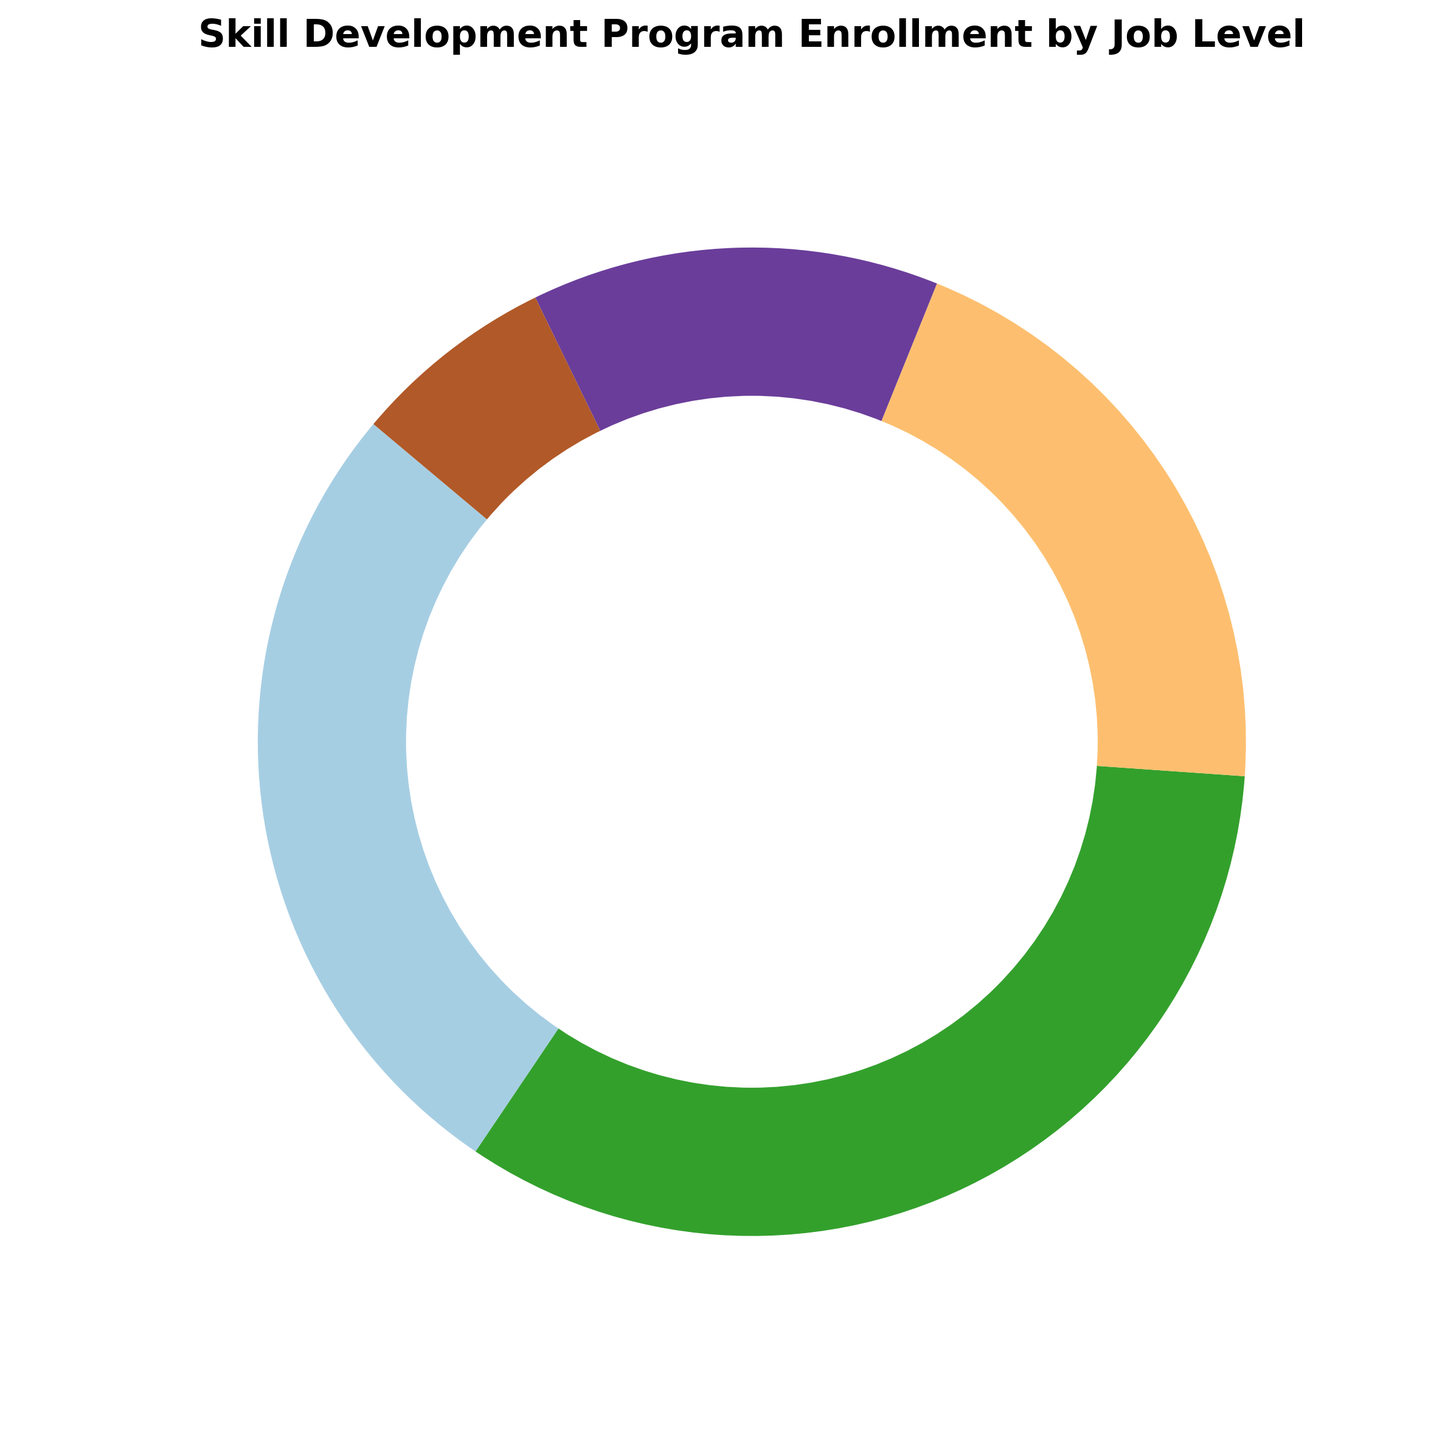What percentage of enrollment is contributed by entry-level employees? The entry-level segment on the pie chart is labeled with its enrollment percentage, showing 120 out of the total 450 enrollments. The label displays 26.7%, calculated as (120/450)*100.
Answer: 26.7% Which job level has the least enrollment in the skill development program? Observing the pie chart, the smallest slice corresponds to the Executive level, with the label showing the enrollment count of 30.
Answer: Executive How does the enrollment for mid-level employees compare to that of managerial employees? The pie chart shows that mid-level employees account for 150 enrollments while managerial employees have 60 enrollments. Thus, mid-level enrollment is 2.5 times higher than managerial enrollment.
Answer: Mid-Level has more What is the total enrollment for senior-level and executive-level employees? Adding the counts for senior-level (90) and executive-level (30) from the pie chart, the combined total is 120.
Answer: 120 Is the enrollment for senior-level employees more than 1/5 of the total enrollment? The total enrollment is 450. For senior-level enrollment to be more than 1/5 of the total, it would need to be greater than 450/5 = 90. The chart shows senior-level enrollment is exactly 90, which is not more than 1/5.
Answer: No Which job level has the largest enrollment in the skill development program? The largest slice in the pie chart represents mid-level employees, with the highest enrollment count of 150.
Answer: Mid-Level How does the percentage of managerial enrollment compare to executive enrollment? The pie chart shows 60 enrollments for managerial and 30 for executive. Therefore, the managerial level has twice the percentage as the executive level. Managerial is 13.3% and executive is 6.7%.
Answer: Managerial is higher What is the combined percentage of entry-level and mid-level enrollments? The pie chart shows entry-level is 26.7% and mid-level is 33.3%. Adding these, (26.7 + 33.3)% equals 60%.
Answer: 60% Is the enrollment for entry-level employees greater than senior-level and executive-level combined? Entry-level enrollment is 120, while the combined total for senior-level (90) and executive (30) is 120. Therefore, entry-level enrollment is equal to, not greater than the combined senior and executive.
Answer: No What does the second largest segment in the pie chart represent? The second largest slice in the pie chart represents entry-level employees, with a count of 120 enrollments and a 26.7% share.
Answer: Entry-Level 